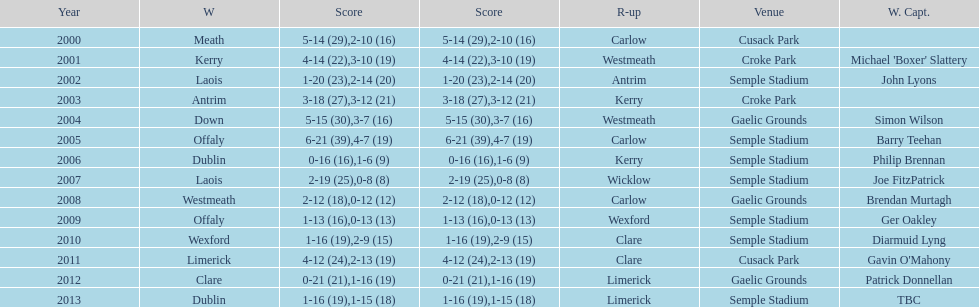Could you parse the entire table as a dict? {'header': ['Year', 'W', 'Score', 'Score', 'R-up', 'Venue', 'W. Capt.'], 'rows': [['2000', 'Meath', '5-14 (29)', '2-10 (16)', 'Carlow', 'Cusack Park', ''], ['2001', 'Kerry', '4-14 (22)', '3-10 (19)', 'Westmeath', 'Croke Park', "Michael 'Boxer' Slattery"], ['2002', 'Laois', '1-20 (23)', '2-14 (20)', 'Antrim', 'Semple Stadium', 'John Lyons'], ['2003', 'Antrim', '3-18 (27)', '3-12 (21)', 'Kerry', 'Croke Park', ''], ['2004', 'Down', '5-15 (30)', '3-7 (16)', 'Westmeath', 'Gaelic Grounds', 'Simon Wilson'], ['2005', 'Offaly', '6-21 (39)', '4-7 (19)', 'Carlow', 'Semple Stadium', 'Barry Teehan'], ['2006', 'Dublin', '0-16 (16)', '1-6 (9)', 'Kerry', 'Semple Stadium', 'Philip Brennan'], ['2007', 'Laois', '2-19 (25)', '0-8 (8)', 'Wicklow', 'Semple Stadium', 'Joe FitzPatrick'], ['2008', 'Westmeath', '2-12 (18)', '0-12 (12)', 'Carlow', 'Gaelic Grounds', 'Brendan Murtagh'], ['2009', 'Offaly', '1-13 (16)', '0-13 (13)', 'Wexford', 'Semple Stadium', 'Ger Oakley'], ['2010', 'Wexford', '1-16 (19)', '2-9 (15)', 'Clare', 'Semple Stadium', 'Diarmuid Lyng'], ['2011', 'Limerick', '4-12 (24)', '2-13 (19)', 'Clare', 'Cusack Park', "Gavin O'Mahony"], ['2012', 'Clare', '0-21 (21)', '1-16 (19)', 'Limerick', 'Gaelic Grounds', 'Patrick Donnellan'], ['2013', 'Dublin', '1-16 (19)', '1-15 (18)', 'Limerick', 'Semple Stadium', 'TBC']]} Who claimed victory after 2007? Laois. 